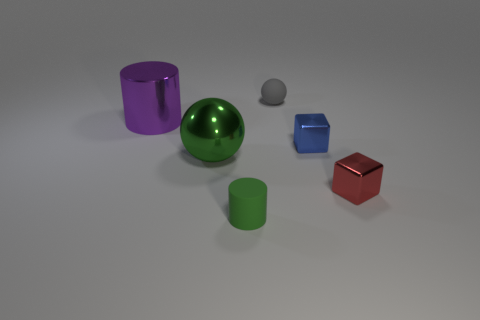There is a cube that is right of the small metal thing behind the red block; how many balls are in front of it?
Give a very brief answer. 0. What is the color of the rubber ball that is the same size as the rubber cylinder?
Ensure brevity in your answer.  Gray. What number of other things are there of the same color as the matte sphere?
Keep it short and to the point. 0. Are there more green cylinders that are left of the gray object than cyan shiny objects?
Provide a succinct answer. Yes. Does the green ball have the same material as the large purple cylinder?
Provide a short and direct response. Yes. How many things are either objects to the left of the gray matte thing or purple metal cylinders?
Make the answer very short. 3. What number of other things are there of the same size as the matte sphere?
Ensure brevity in your answer.  3. Is the number of metal cylinders behind the blue object the same as the number of tiny metal blocks that are to the left of the small red object?
Make the answer very short. Yes. What is the color of the other small object that is the same shape as the red shiny object?
Provide a short and direct response. Blue. There is a small rubber object that is in front of the green metallic object; is it the same color as the shiny ball?
Offer a very short reply. Yes. 